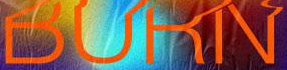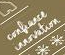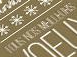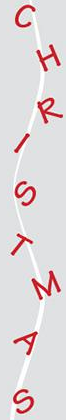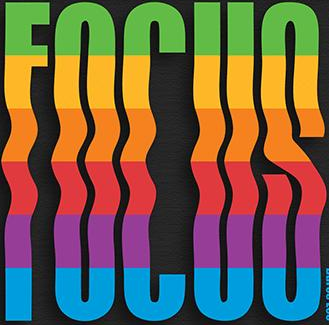What words are shown in these images in order, separated by a semicolon? BURN; #; #; CHRISTMAS; FOCUS 